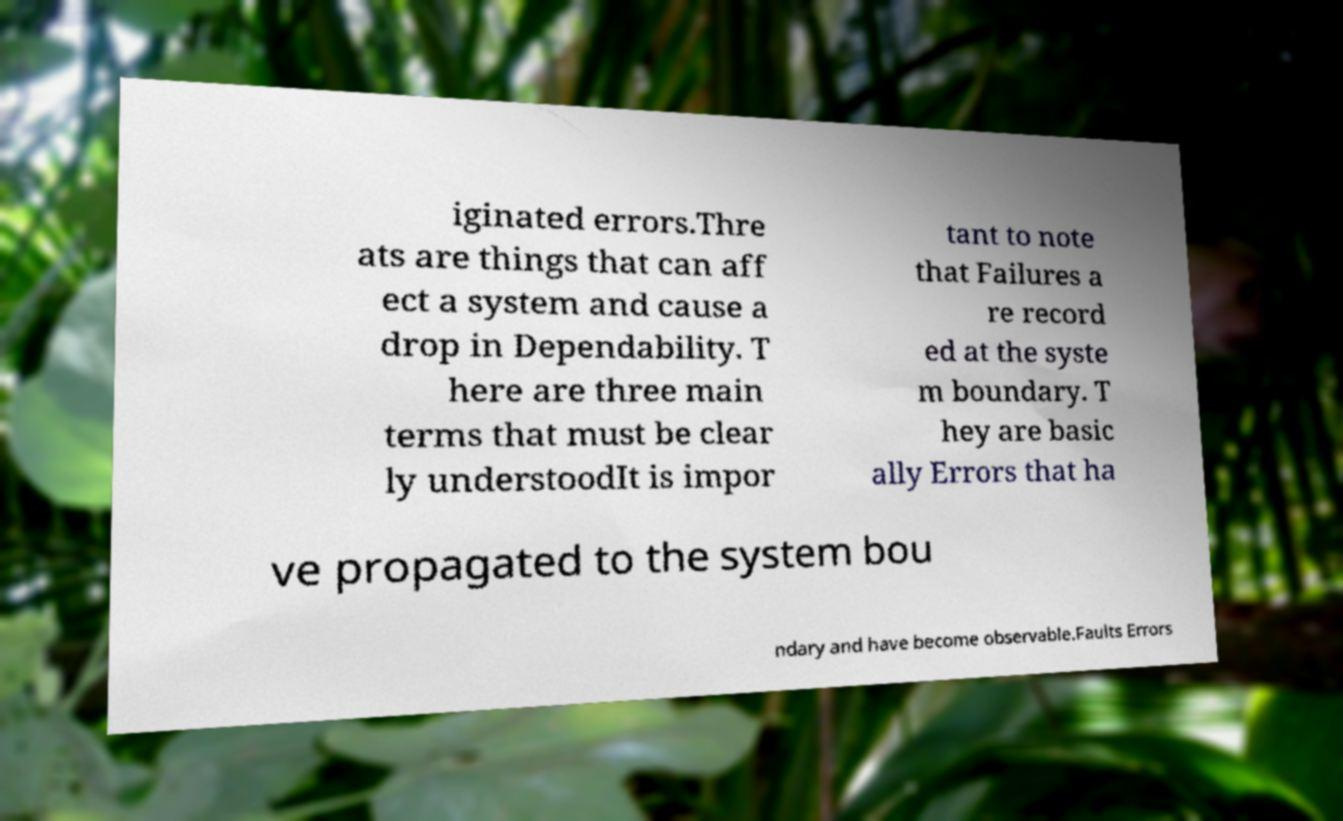Could you extract and type out the text from this image? iginated errors.Thre ats are things that can aff ect a system and cause a drop in Dependability. T here are three main terms that must be clear ly understoodIt is impor tant to note that Failures a re record ed at the syste m boundary. T hey are basic ally Errors that ha ve propagated to the system bou ndary and have become observable.Faults Errors 